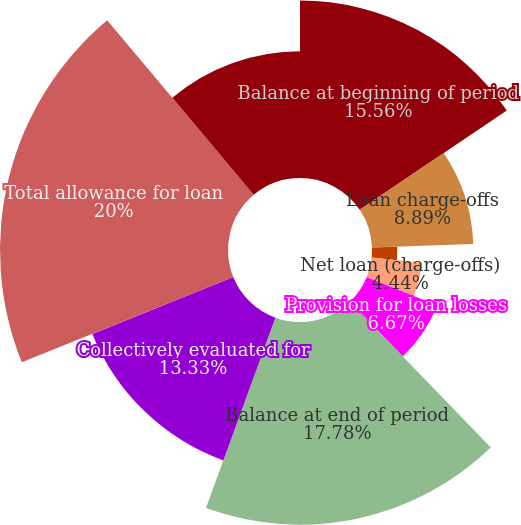Convert chart to OTSL. <chart><loc_0><loc_0><loc_500><loc_500><pie_chart><fcel>Balance at beginning of period<fcel>Loan charge-offs<fcel>Recoveries on loans previously<fcel>Net loan (charge-offs)<fcel>Provision for loan losses<fcel>Balance at end of period<fcel>As a percentage of total loans<fcel>Collectively evaluated for<fcel>Total allowance for loan<fcel>Individually evaluated for<nl><fcel>15.56%<fcel>8.89%<fcel>2.22%<fcel>4.44%<fcel>6.67%<fcel>17.78%<fcel>0.0%<fcel>13.33%<fcel>20.0%<fcel>11.11%<nl></chart> 